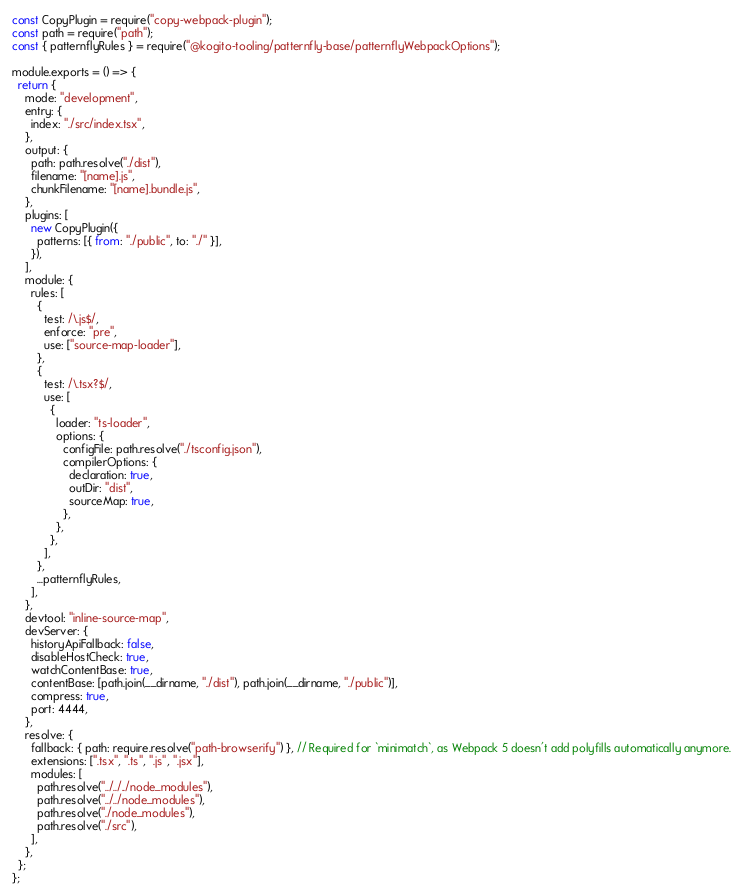<code> <loc_0><loc_0><loc_500><loc_500><_JavaScript_>const CopyPlugin = require("copy-webpack-plugin");
const path = require("path");
const { patternflyRules } = require("@kogito-tooling/patternfly-base/patternflyWebpackOptions");

module.exports = () => {
  return {
    mode: "development",
    entry: {
      index: "./src/index.tsx",
    },
    output: {
      path: path.resolve("./dist"),
      filename: "[name].js",
      chunkFilename: "[name].bundle.js",
    },
    plugins: [
      new CopyPlugin({
        patterns: [{ from: "./public", to: "./" }],
      }),
    ],
    module: {
      rules: [
        {
          test: /\.js$/,
          enforce: "pre",
          use: ["source-map-loader"],
        },
        {
          test: /\.tsx?$/,
          use: [
            {
              loader: "ts-loader",
              options: {
                configFile: path.resolve("./tsconfig.json"),
                compilerOptions: {
                  declaration: true,
                  outDir: "dist",
                  sourceMap: true,
                },
              },
            },
          ],
        },
        ...patternflyRules,
      ],
    },
    devtool: "inline-source-map",
    devServer: {
      historyApiFallback: false,
      disableHostCheck: true,
      watchContentBase: true,
      contentBase: [path.join(__dirname, "./dist"), path.join(__dirname, "./public")],
      compress: true,
      port: 4444,
    },
    resolve: {
      fallback: { path: require.resolve("path-browserify") }, // Required for `minimatch`, as Webpack 5 doesn't add polyfills automatically anymore.
      extensions: [".tsx", ".ts", ".js", ".jsx"],
      modules: [
        path.resolve("../../../node_modules"),
        path.resolve("../../node_modules"),
        path.resolve("./node_modules"),
        path.resolve("./src"),
      ],
    },
  };
};
</code> 